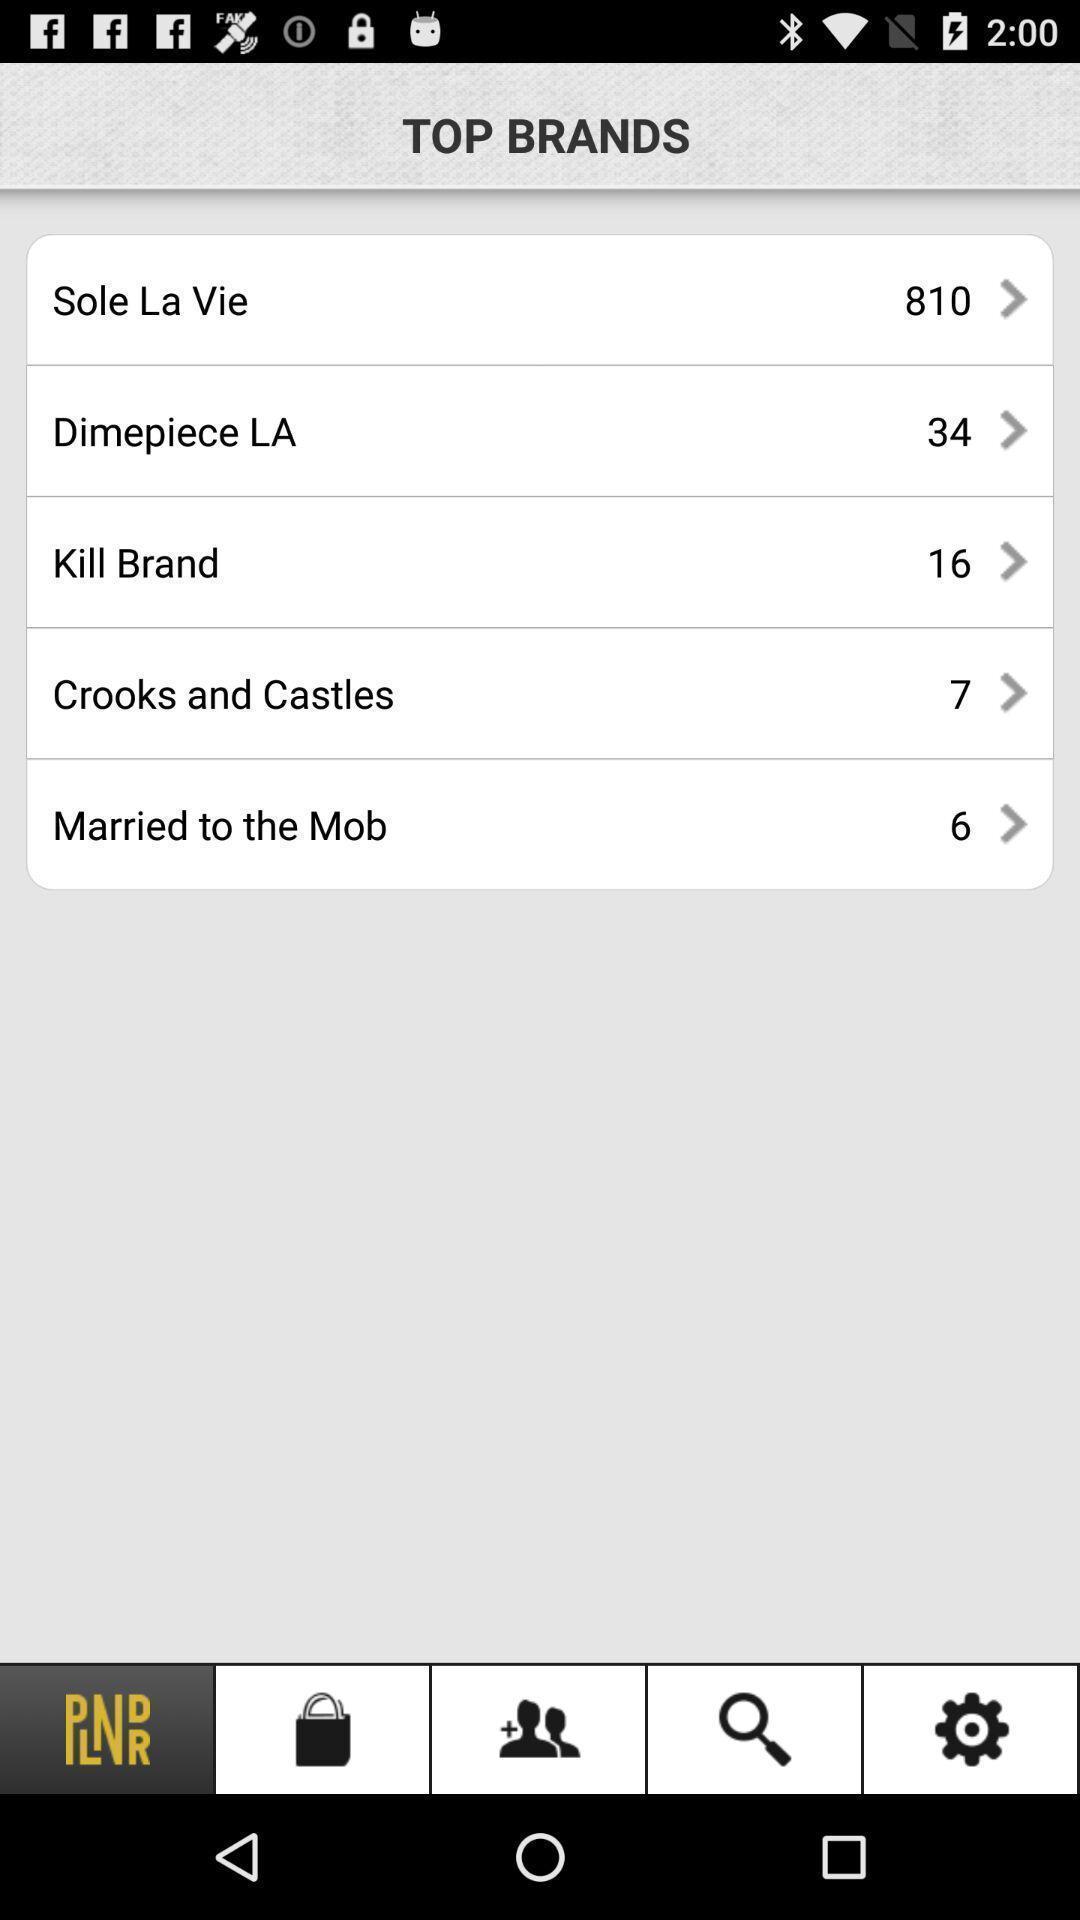Give me a narrative description of this picture. Top brands page in a shopping app. 